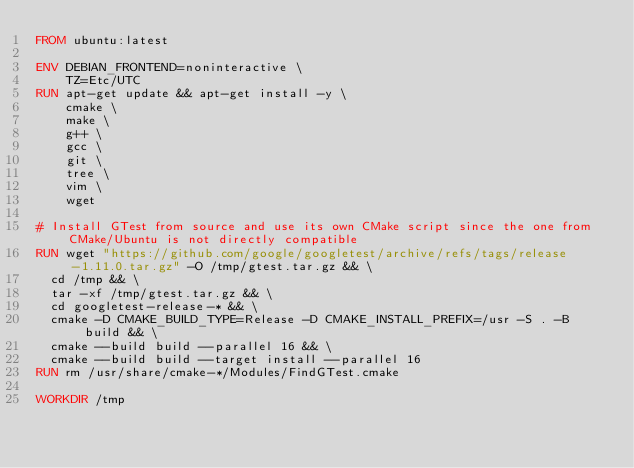Convert code to text. <code><loc_0><loc_0><loc_500><loc_500><_Dockerfile_>FROM ubuntu:latest

ENV DEBIAN_FRONTEND=noninteractive \
    TZ=Etc/UTC
RUN apt-get update && apt-get install -y \
    cmake \
    make \
    g++ \
    gcc \
    git \
    tree \
    vim \
    wget

# Install GTest from source and use its own CMake script since the one from CMake/Ubuntu is not directly compatible
RUN wget "https://github.com/google/googletest/archive/refs/tags/release-1.11.0.tar.gz" -O /tmp/gtest.tar.gz && \
  cd /tmp && \
  tar -xf /tmp/gtest.tar.gz && \
  cd googletest-release-* && \
  cmake -D CMAKE_BUILD_TYPE=Release -D CMAKE_INSTALL_PREFIX=/usr -S . -B build && \
  cmake --build build --parallel 16 && \
  cmake --build build --target install --parallel 16
RUN rm /usr/share/cmake-*/Modules/FindGTest.cmake

WORKDIR /tmp
</code> 